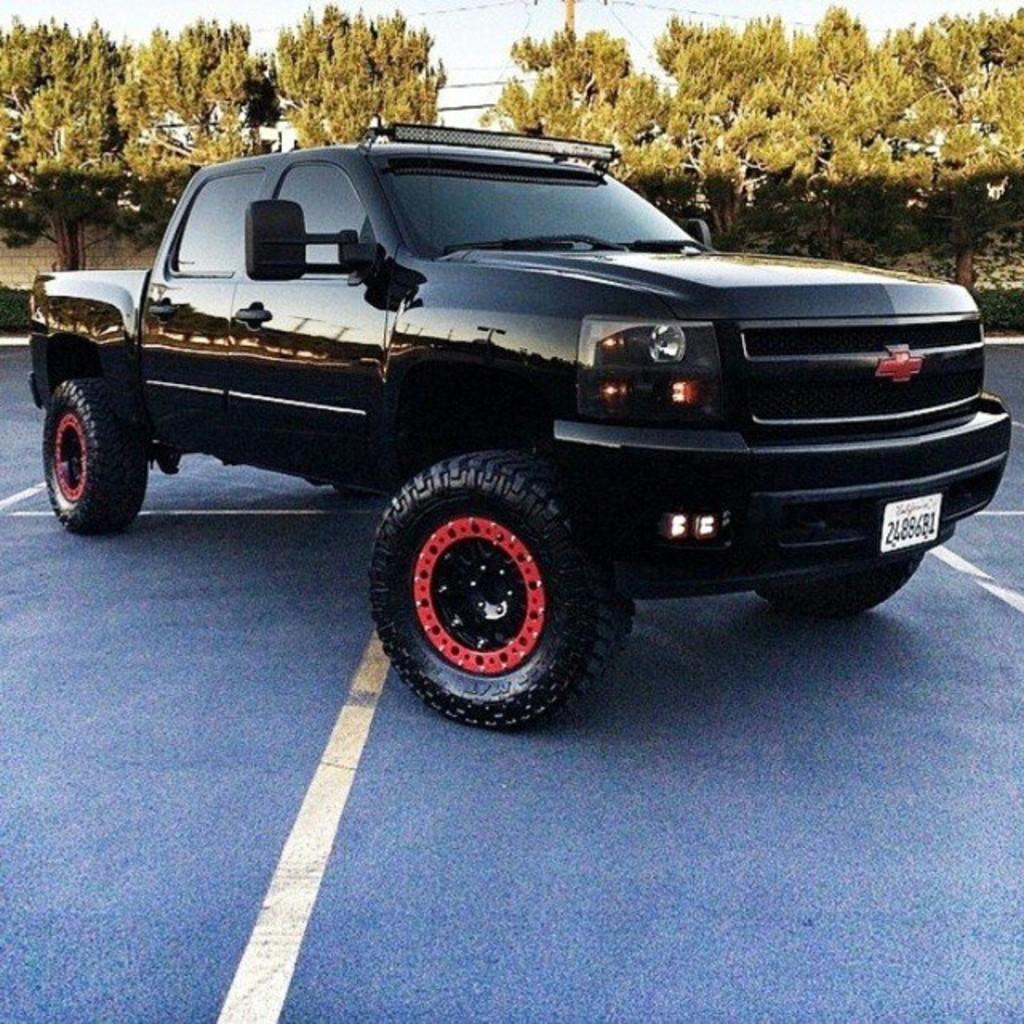In one or two sentences, can you explain what this image depicts? In the center of the image we can see a truck. In the background of the image we can see the trees, wall, plants, pole, wires. At the bottom of the image we can see the road. At the top of the image we can see the sky. 